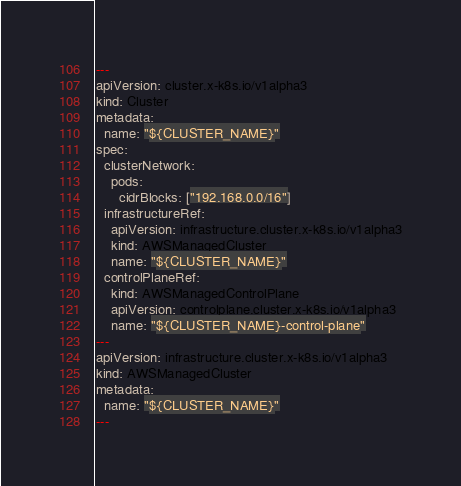<code> <loc_0><loc_0><loc_500><loc_500><_YAML_>---
apiVersion: cluster.x-k8s.io/v1alpha3
kind: Cluster
metadata:
  name: "${CLUSTER_NAME}"
spec:
  clusterNetwork:
    pods:
      cidrBlocks: ["192.168.0.0/16"]
  infrastructureRef:
    apiVersion: infrastructure.cluster.x-k8s.io/v1alpha3
    kind: AWSManagedCluster
    name: "${CLUSTER_NAME}"
  controlPlaneRef:
    kind: AWSManagedControlPlane
    apiVersion: controlplane.cluster.x-k8s.io/v1alpha3
    name: "${CLUSTER_NAME}-control-plane"
---
apiVersion: infrastructure.cluster.x-k8s.io/v1alpha3
kind: AWSManagedCluster
metadata:
  name: "${CLUSTER_NAME}"
---</code> 